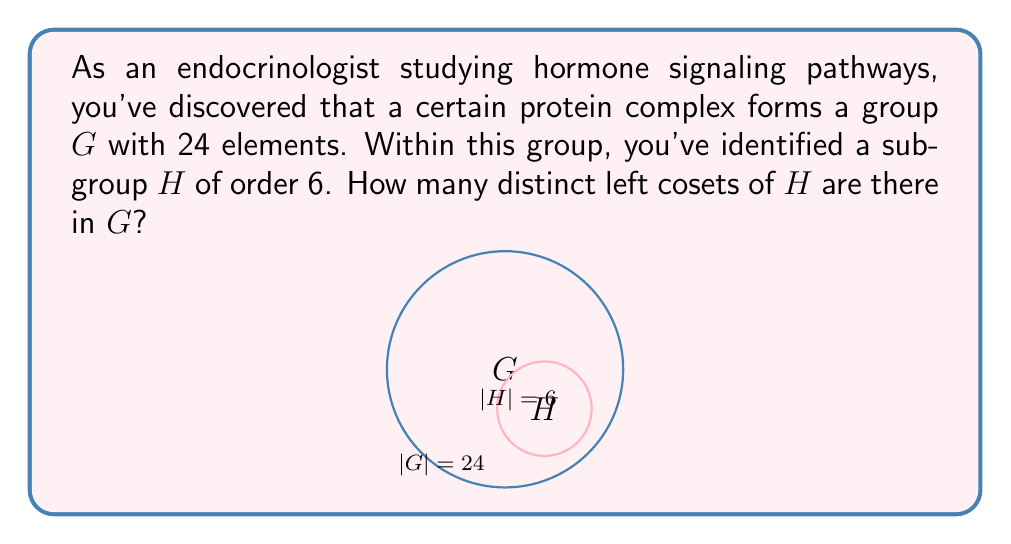Could you help me with this problem? Let's approach this step-by-step:

1) First, recall the Lagrange's Theorem, which states that for a finite group $G$ and a subgroup $H$ of $G$:

   $$|G| = |H| \cdot [G:H]$$

   where $|G|$ is the order of $G$, $|H|$ is the order of $H$, and $[G:H]$ is the index of $H$ in $G$.

2) The index $[G:H]$ is equal to the number of distinct left cosets of $H$ in $G$.

3) We are given:
   $|G| = 24$ (the group has 24 elements)
   $|H| = 6$ (the subgroup has 6 elements)

4) Substituting these values into Lagrange's Theorem:

   $$24 = 6 \cdot [G:H]$$

5) Solving for $[G:H]$:

   $$[G:H] = \frac{24}{6} = 4$$

6) Therefore, there are 4 distinct left cosets of $H$ in $G$.

This result is consistent with the biological interpretation: the protein complex (group $G$) can be partitioned into 4 distinct subsets (cosets) based on the subgroup $H$, which might represent different functional states or configurations of the complex.
Answer: 4 